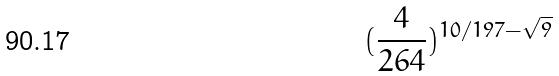Convert formula to latex. <formula><loc_0><loc_0><loc_500><loc_500>( \frac { 4 } { 2 6 4 } ) ^ { 1 0 / 1 9 7 - \sqrt { 9 } }</formula> 